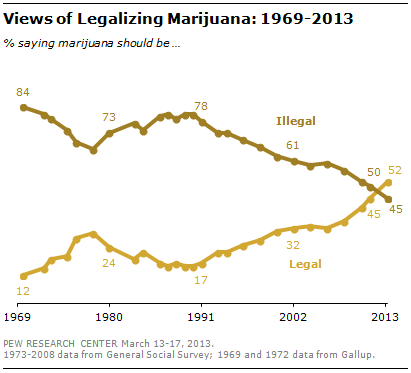Identify some key points in this picture. The value of the lower graph in 1969 was 12. The percentage of people who believe marijuana should be legalized increased from 1969 to 2013, with a difference of 0.4%. 